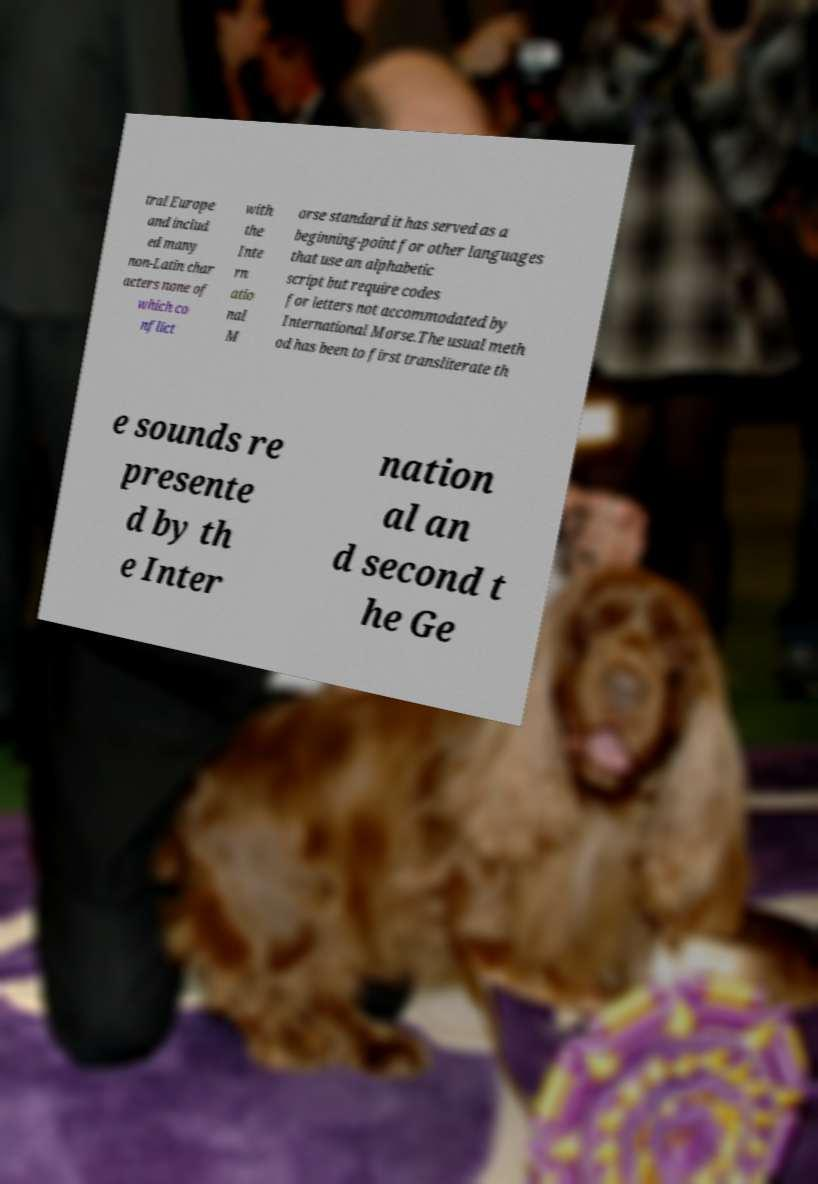Please read and relay the text visible in this image. What does it say? tral Europe and includ ed many non-Latin char acters none of which co nflict with the Inte rn atio nal M orse standard it has served as a beginning-point for other languages that use an alphabetic script but require codes for letters not accommodated by International Morse.The usual meth od has been to first transliterate th e sounds re presente d by th e Inter nation al an d second t he Ge 